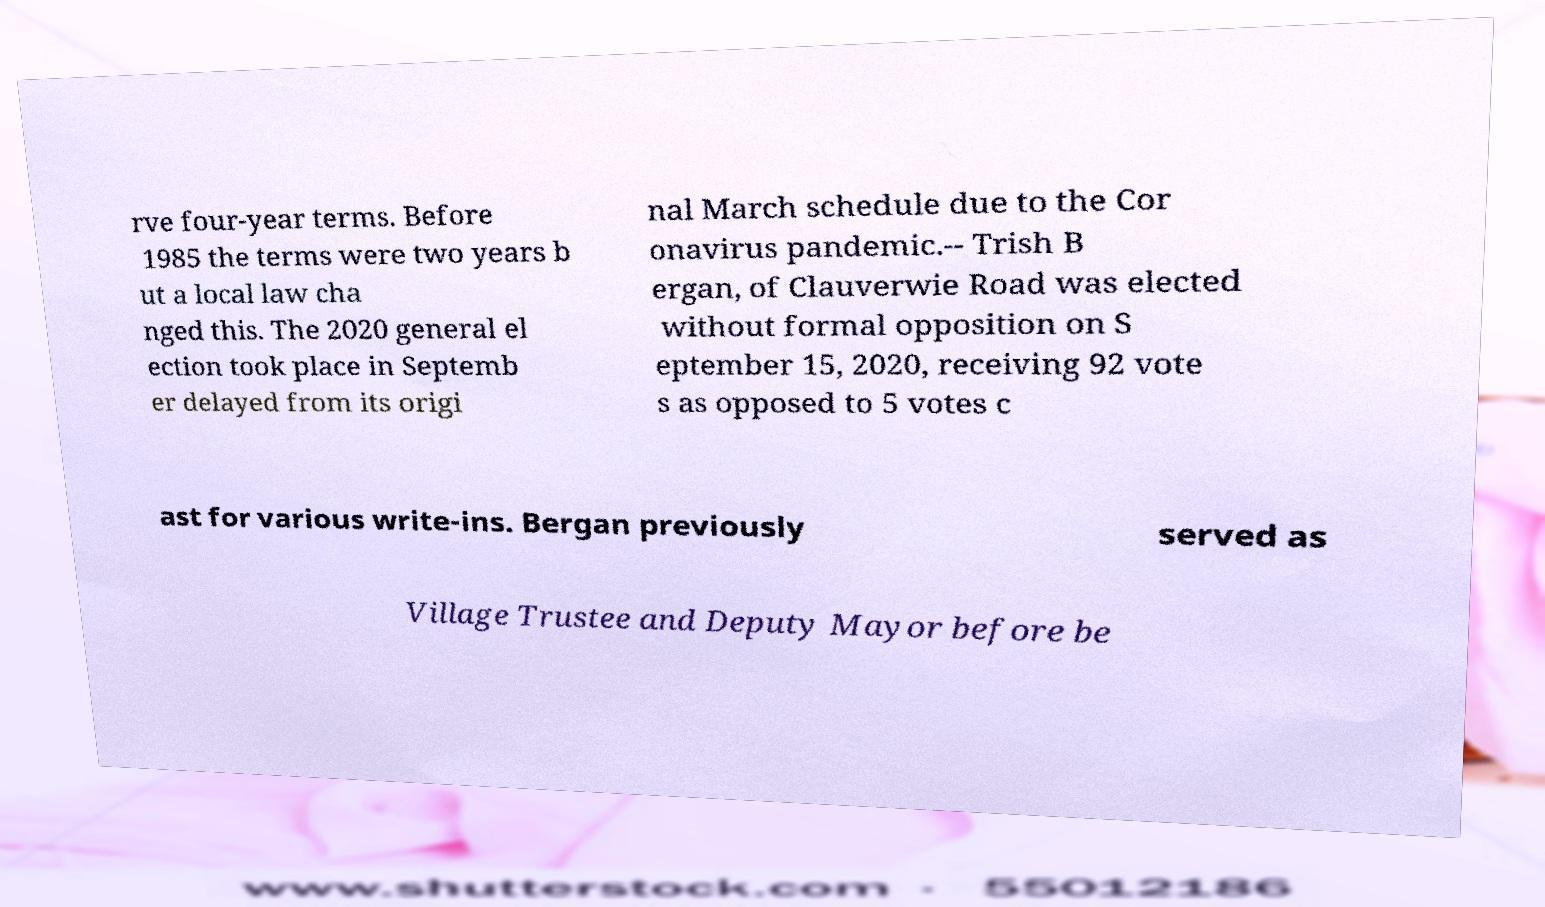There's text embedded in this image that I need extracted. Can you transcribe it verbatim? rve four-year terms. Before 1985 the terms were two years b ut a local law cha nged this. The 2020 general el ection took place in Septemb er delayed from its origi nal March schedule due to the Cor onavirus pandemic.-- Trish B ergan, of Clauverwie Road was elected without formal opposition on S eptember 15, 2020, receiving 92 vote s as opposed to 5 votes c ast for various write-ins. Bergan previously served as Village Trustee and Deputy Mayor before be 